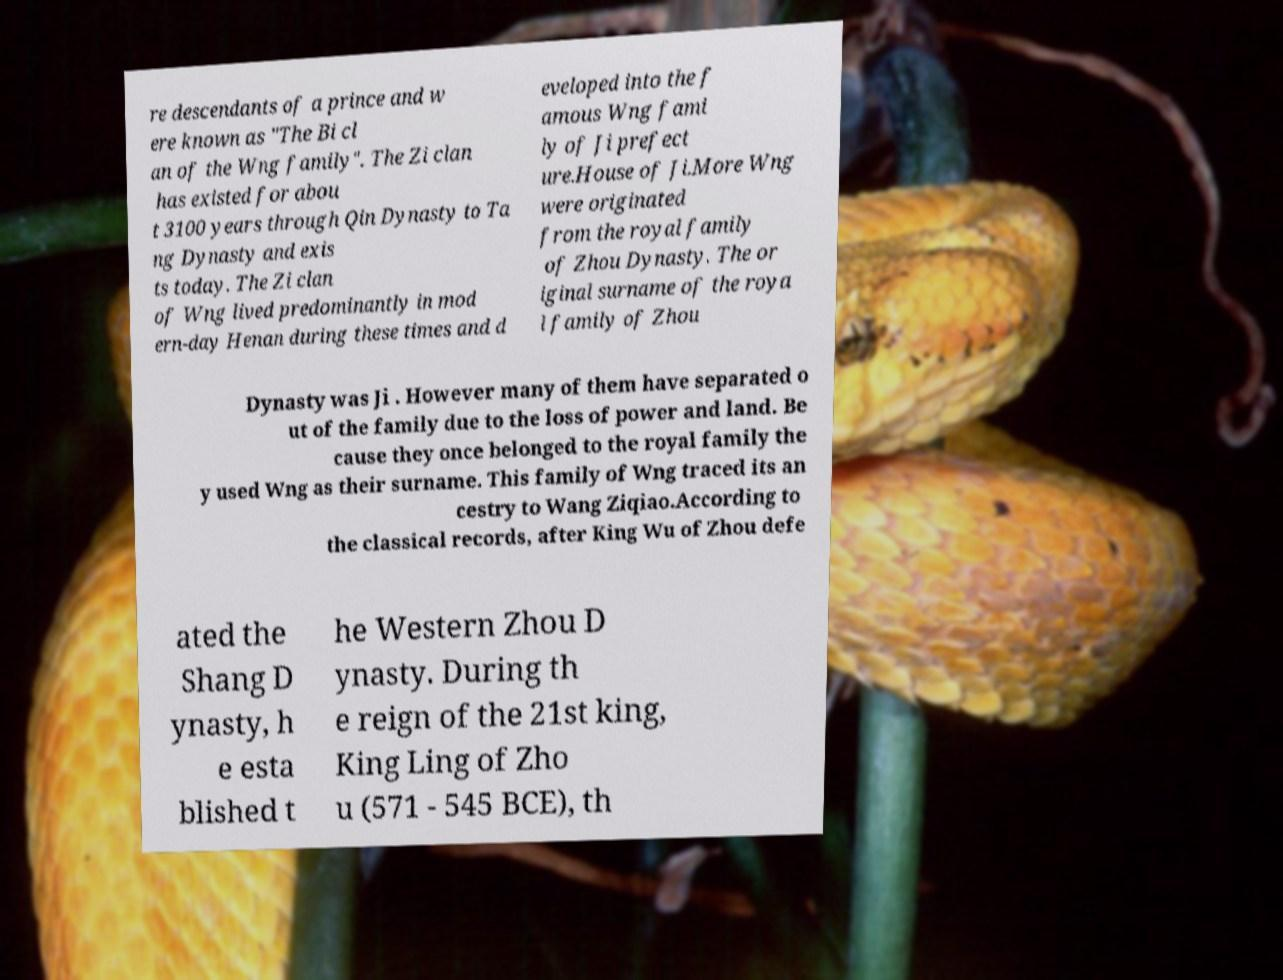Please identify and transcribe the text found in this image. re descendants of a prince and w ere known as "The Bi cl an of the Wng family". The Zi clan has existed for abou t 3100 years through Qin Dynasty to Ta ng Dynasty and exis ts today. The Zi clan of Wng lived predominantly in mod ern-day Henan during these times and d eveloped into the f amous Wng fami ly of Ji prefect ure.House of Ji.More Wng were originated from the royal family of Zhou Dynasty. The or iginal surname of the roya l family of Zhou Dynasty was Ji . However many of them have separated o ut of the family due to the loss of power and land. Be cause they once belonged to the royal family the y used Wng as their surname. This family of Wng traced its an cestry to Wang Ziqiao.According to the classical records, after King Wu of Zhou defe ated the Shang D ynasty, h e esta blished t he Western Zhou D ynasty. During th e reign of the 21st king, King Ling of Zho u (571 - 545 BCE), th 